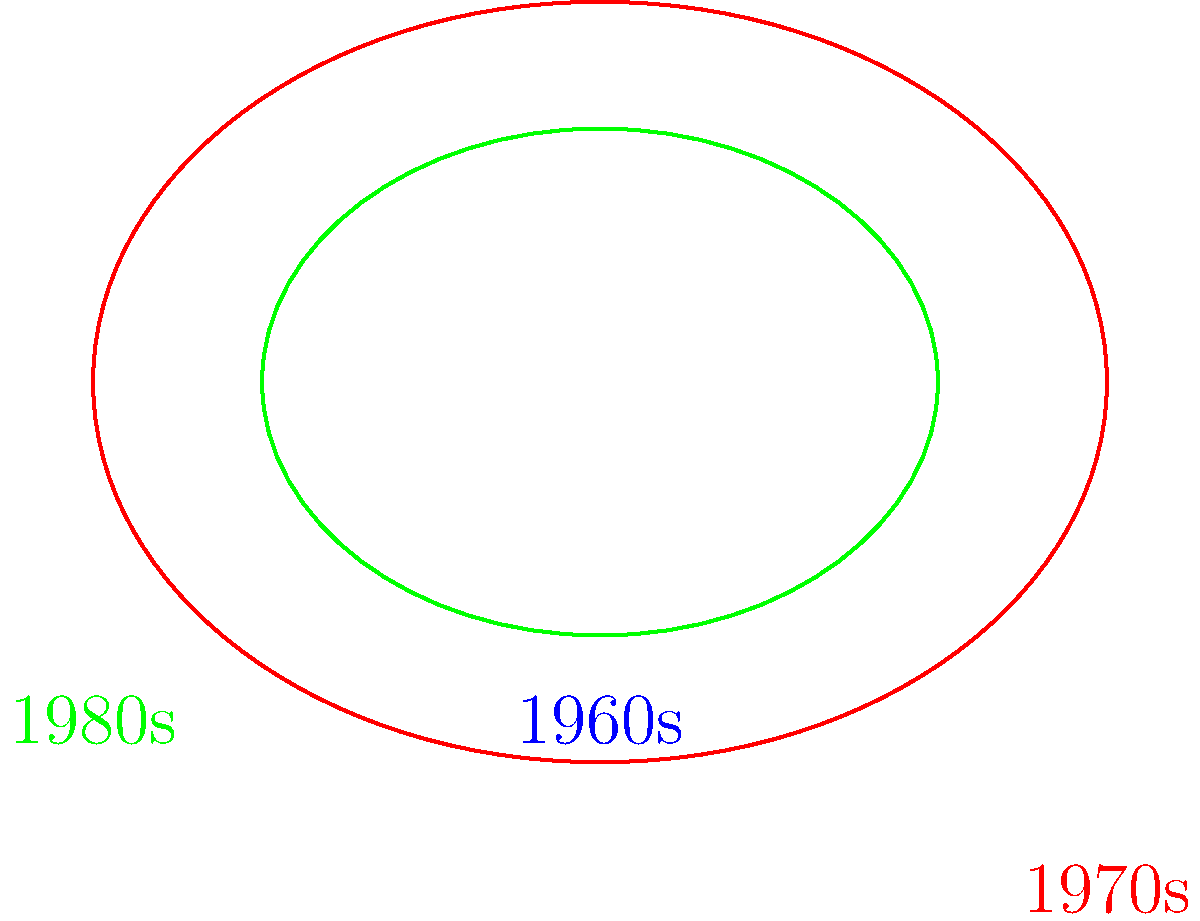In this representation of Barbra Streisand's iconic hairstyles across three decades, which two hairstyles are congruent? To determine which hairstyles are congruent, we need to analyze their shapes and sizes:

1. The blue ellipse represents Barbra's 1960s hairstyle.
2. The red ellipse represents her 1970s hairstyle, which is a scaled-up version of the 1960s style.
3. The green ellipse represents her 1980s hairstyle.

Two shapes are congruent if they have the same size and shape. In this case:

- The red ellipse is larger than the blue one, so they are not congruent.
- The green ellipse is the same size as the blue one, but it's a reflection across the vertical axis.

In geometry, reflections preserve size and shape, making the resulting figure congruent to the original. Therefore, the blue (1960s) and green (1980s) hairstyles are congruent.
Answer: 1960s and 1980s 